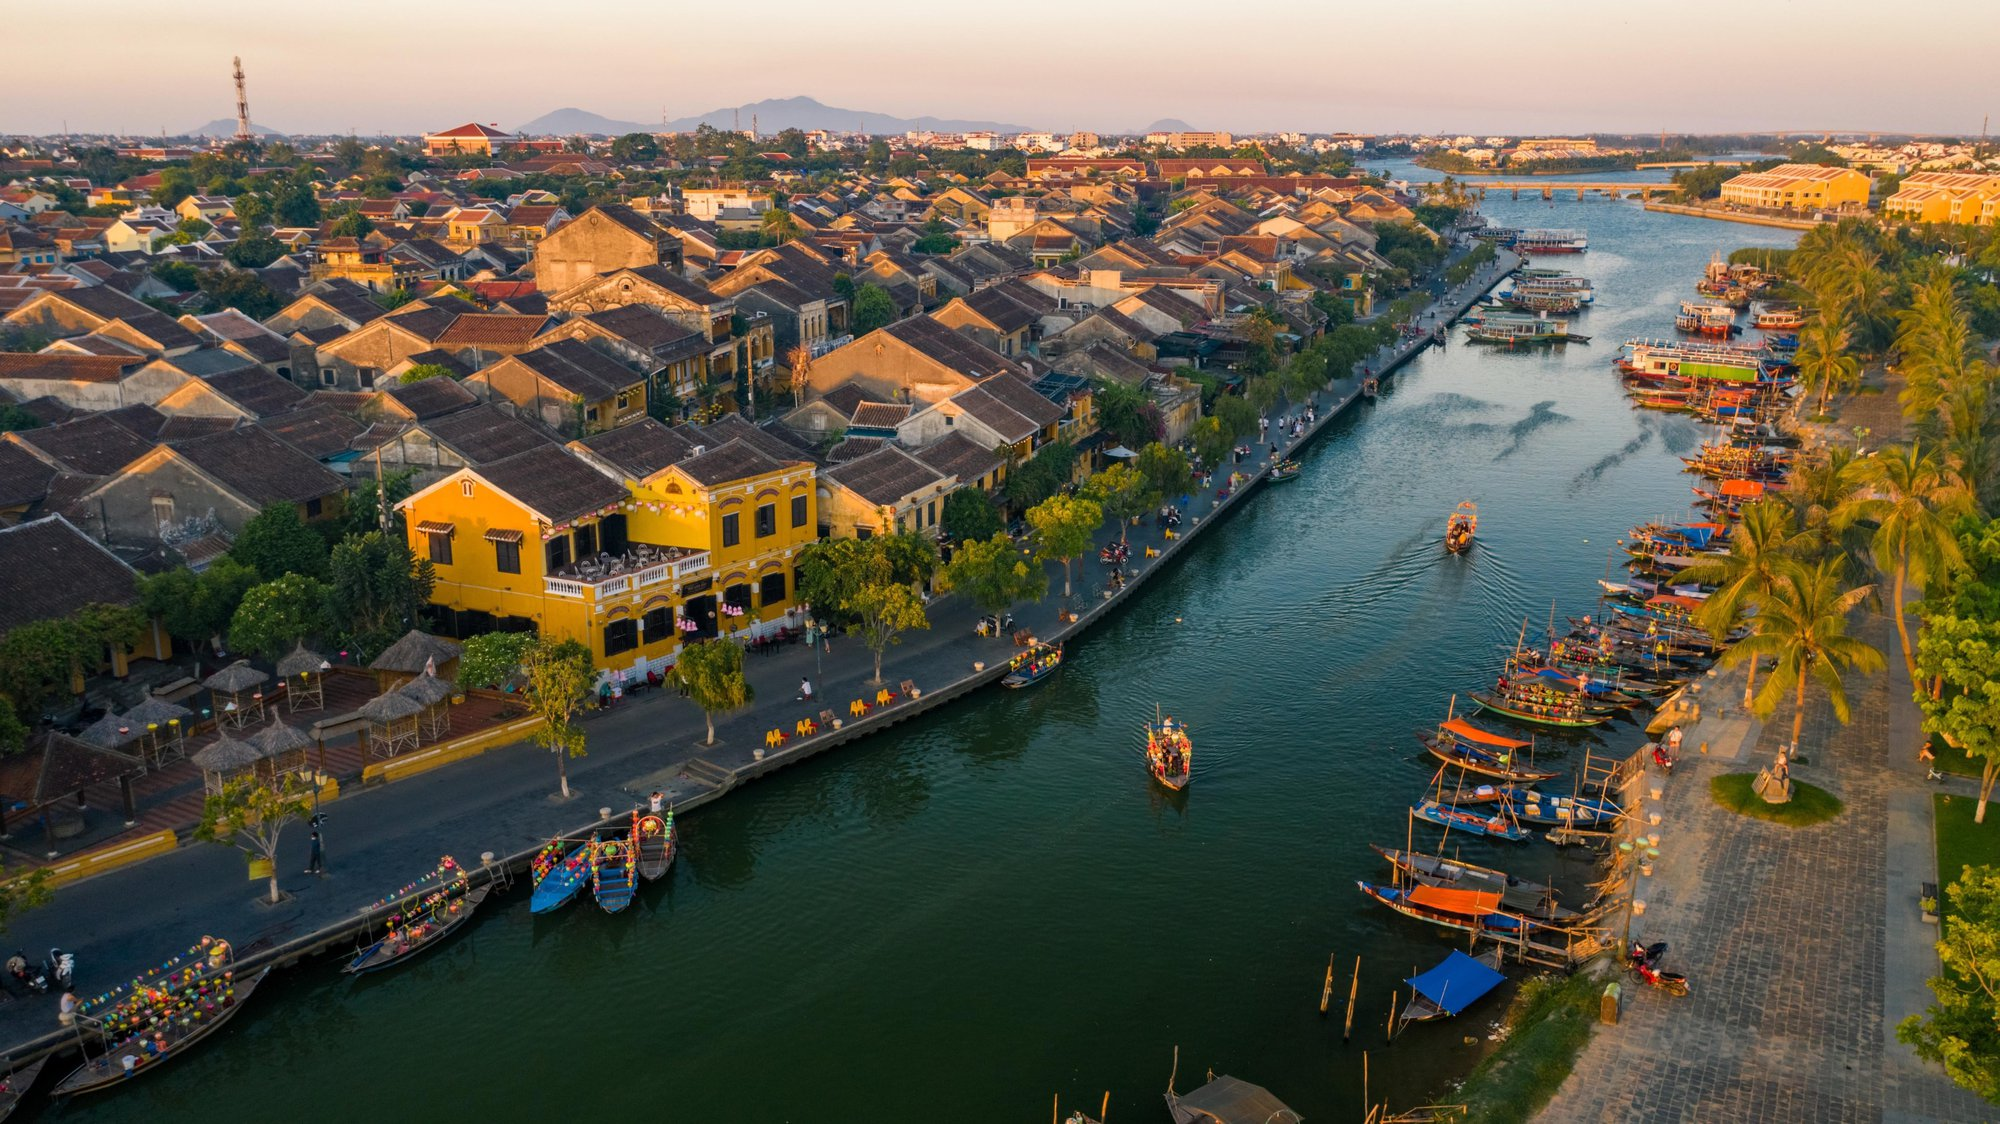Explain the visual content of the image in great detail. The image captures the enchanting beauty of Hoi An, an ancient town in Vietnam, bathed in the warm hues of the setting sun. The Thu Bon River, a vital lifeline of the town, meanders through the heart of the image, reflecting the golden light of the sunset. The riverbanks are adorned with an array of colorful boats, their vibrant hues adding a dash of charm to the tranquil waters. Traditional Vietnamese architecture, characterized by its unique blend of indigenous and foreign influences, forms the backdrop of the scene. The buildings, painted in a variety of vibrant colors, lend a distinctive character to the town. The aerial perspective of the image offers a comprehensive view of the town's layout, revealing the harmonious coexistence of nature and human habitation in this UNESCO World Heritage site. 